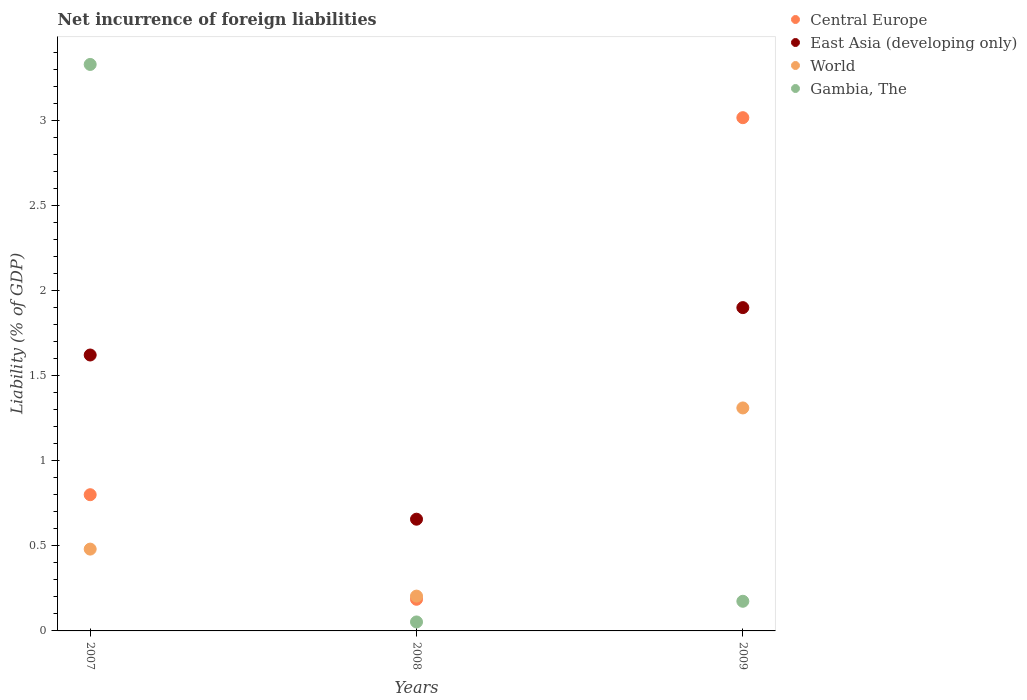What is the net incurrence of foreign liabilities in East Asia (developing only) in 2007?
Ensure brevity in your answer.  1.62. Across all years, what is the maximum net incurrence of foreign liabilities in Gambia, The?
Offer a very short reply. 3.33. Across all years, what is the minimum net incurrence of foreign liabilities in East Asia (developing only)?
Provide a short and direct response. 0.66. What is the total net incurrence of foreign liabilities in East Asia (developing only) in the graph?
Make the answer very short. 4.18. What is the difference between the net incurrence of foreign liabilities in Gambia, The in 2007 and that in 2008?
Give a very brief answer. 3.28. What is the difference between the net incurrence of foreign liabilities in World in 2007 and the net incurrence of foreign liabilities in Central Europe in 2008?
Your response must be concise. 0.29. What is the average net incurrence of foreign liabilities in World per year?
Provide a succinct answer. 0.67. In the year 2009, what is the difference between the net incurrence of foreign liabilities in World and net incurrence of foreign liabilities in East Asia (developing only)?
Make the answer very short. -0.59. What is the ratio of the net incurrence of foreign liabilities in Central Europe in 2007 to that in 2009?
Ensure brevity in your answer.  0.27. Is the difference between the net incurrence of foreign liabilities in World in 2008 and 2009 greater than the difference between the net incurrence of foreign liabilities in East Asia (developing only) in 2008 and 2009?
Your answer should be compact. Yes. What is the difference between the highest and the second highest net incurrence of foreign liabilities in East Asia (developing only)?
Your answer should be very brief. 0.28. What is the difference between the highest and the lowest net incurrence of foreign liabilities in East Asia (developing only)?
Offer a terse response. 1.24. In how many years, is the net incurrence of foreign liabilities in East Asia (developing only) greater than the average net incurrence of foreign liabilities in East Asia (developing only) taken over all years?
Offer a terse response. 2. Is it the case that in every year, the sum of the net incurrence of foreign liabilities in Gambia, The and net incurrence of foreign liabilities in East Asia (developing only)  is greater than the sum of net incurrence of foreign liabilities in World and net incurrence of foreign liabilities in Central Europe?
Offer a very short reply. No. How many years are there in the graph?
Offer a very short reply. 3. Are the values on the major ticks of Y-axis written in scientific E-notation?
Provide a succinct answer. No. Does the graph contain any zero values?
Offer a very short reply. No. Where does the legend appear in the graph?
Provide a short and direct response. Top right. How many legend labels are there?
Your answer should be very brief. 4. What is the title of the graph?
Offer a very short reply. Net incurrence of foreign liabilities. What is the label or title of the Y-axis?
Keep it short and to the point. Liability (% of GDP). What is the Liability (% of GDP) of Central Europe in 2007?
Offer a very short reply. 0.8. What is the Liability (% of GDP) of East Asia (developing only) in 2007?
Provide a succinct answer. 1.62. What is the Liability (% of GDP) of World in 2007?
Provide a succinct answer. 0.48. What is the Liability (% of GDP) in Gambia, The in 2007?
Your response must be concise. 3.33. What is the Liability (% of GDP) in Central Europe in 2008?
Offer a terse response. 0.19. What is the Liability (% of GDP) of East Asia (developing only) in 2008?
Keep it short and to the point. 0.66. What is the Liability (% of GDP) in World in 2008?
Your answer should be compact. 0.2. What is the Liability (% of GDP) in Gambia, The in 2008?
Provide a succinct answer. 0.05. What is the Liability (% of GDP) in Central Europe in 2009?
Provide a succinct answer. 3.02. What is the Liability (% of GDP) in East Asia (developing only) in 2009?
Offer a very short reply. 1.9. What is the Liability (% of GDP) of World in 2009?
Ensure brevity in your answer.  1.31. What is the Liability (% of GDP) of Gambia, The in 2009?
Your response must be concise. 0.17. Across all years, what is the maximum Liability (% of GDP) in Central Europe?
Your response must be concise. 3.02. Across all years, what is the maximum Liability (% of GDP) of East Asia (developing only)?
Offer a terse response. 1.9. Across all years, what is the maximum Liability (% of GDP) in World?
Ensure brevity in your answer.  1.31. Across all years, what is the maximum Liability (% of GDP) in Gambia, The?
Make the answer very short. 3.33. Across all years, what is the minimum Liability (% of GDP) in Central Europe?
Give a very brief answer. 0.19. Across all years, what is the minimum Liability (% of GDP) in East Asia (developing only)?
Your response must be concise. 0.66. Across all years, what is the minimum Liability (% of GDP) of World?
Keep it short and to the point. 0.2. Across all years, what is the minimum Liability (% of GDP) in Gambia, The?
Make the answer very short. 0.05. What is the total Liability (% of GDP) in Central Europe in the graph?
Provide a short and direct response. 4. What is the total Liability (% of GDP) of East Asia (developing only) in the graph?
Offer a very short reply. 4.18. What is the total Liability (% of GDP) in World in the graph?
Ensure brevity in your answer.  2. What is the total Liability (% of GDP) of Gambia, The in the graph?
Provide a succinct answer. 3.56. What is the difference between the Liability (% of GDP) of Central Europe in 2007 and that in 2008?
Provide a short and direct response. 0.61. What is the difference between the Liability (% of GDP) in East Asia (developing only) in 2007 and that in 2008?
Ensure brevity in your answer.  0.96. What is the difference between the Liability (% of GDP) of World in 2007 and that in 2008?
Provide a short and direct response. 0.28. What is the difference between the Liability (% of GDP) of Gambia, The in 2007 and that in 2008?
Make the answer very short. 3.28. What is the difference between the Liability (% of GDP) of Central Europe in 2007 and that in 2009?
Offer a very short reply. -2.22. What is the difference between the Liability (% of GDP) in East Asia (developing only) in 2007 and that in 2009?
Your answer should be very brief. -0.28. What is the difference between the Liability (% of GDP) in World in 2007 and that in 2009?
Offer a very short reply. -0.83. What is the difference between the Liability (% of GDP) of Gambia, The in 2007 and that in 2009?
Make the answer very short. 3.15. What is the difference between the Liability (% of GDP) of Central Europe in 2008 and that in 2009?
Make the answer very short. -2.83. What is the difference between the Liability (% of GDP) of East Asia (developing only) in 2008 and that in 2009?
Ensure brevity in your answer.  -1.24. What is the difference between the Liability (% of GDP) in World in 2008 and that in 2009?
Offer a terse response. -1.11. What is the difference between the Liability (% of GDP) in Gambia, The in 2008 and that in 2009?
Provide a succinct answer. -0.12. What is the difference between the Liability (% of GDP) in Central Europe in 2007 and the Liability (% of GDP) in East Asia (developing only) in 2008?
Provide a short and direct response. 0.14. What is the difference between the Liability (% of GDP) in Central Europe in 2007 and the Liability (% of GDP) in World in 2008?
Your answer should be compact. 0.6. What is the difference between the Liability (% of GDP) in Central Europe in 2007 and the Liability (% of GDP) in Gambia, The in 2008?
Your answer should be very brief. 0.75. What is the difference between the Liability (% of GDP) of East Asia (developing only) in 2007 and the Liability (% of GDP) of World in 2008?
Provide a succinct answer. 1.42. What is the difference between the Liability (% of GDP) of East Asia (developing only) in 2007 and the Liability (% of GDP) of Gambia, The in 2008?
Ensure brevity in your answer.  1.57. What is the difference between the Liability (% of GDP) in World in 2007 and the Liability (% of GDP) in Gambia, The in 2008?
Your answer should be compact. 0.43. What is the difference between the Liability (% of GDP) in Central Europe in 2007 and the Liability (% of GDP) in East Asia (developing only) in 2009?
Your response must be concise. -1.1. What is the difference between the Liability (% of GDP) of Central Europe in 2007 and the Liability (% of GDP) of World in 2009?
Make the answer very short. -0.51. What is the difference between the Liability (% of GDP) of Central Europe in 2007 and the Liability (% of GDP) of Gambia, The in 2009?
Your answer should be compact. 0.63. What is the difference between the Liability (% of GDP) in East Asia (developing only) in 2007 and the Liability (% of GDP) in World in 2009?
Your answer should be compact. 0.31. What is the difference between the Liability (% of GDP) of East Asia (developing only) in 2007 and the Liability (% of GDP) of Gambia, The in 2009?
Give a very brief answer. 1.45. What is the difference between the Liability (% of GDP) of World in 2007 and the Liability (% of GDP) of Gambia, The in 2009?
Offer a terse response. 0.31. What is the difference between the Liability (% of GDP) in Central Europe in 2008 and the Liability (% of GDP) in East Asia (developing only) in 2009?
Your answer should be compact. -1.71. What is the difference between the Liability (% of GDP) of Central Europe in 2008 and the Liability (% of GDP) of World in 2009?
Give a very brief answer. -1.12. What is the difference between the Liability (% of GDP) in Central Europe in 2008 and the Liability (% of GDP) in Gambia, The in 2009?
Provide a short and direct response. 0.01. What is the difference between the Liability (% of GDP) of East Asia (developing only) in 2008 and the Liability (% of GDP) of World in 2009?
Make the answer very short. -0.65. What is the difference between the Liability (% of GDP) of East Asia (developing only) in 2008 and the Liability (% of GDP) of Gambia, The in 2009?
Offer a very short reply. 0.48. What is the difference between the Liability (% of GDP) in World in 2008 and the Liability (% of GDP) in Gambia, The in 2009?
Your answer should be compact. 0.03. What is the average Liability (% of GDP) of Central Europe per year?
Your response must be concise. 1.33. What is the average Liability (% of GDP) of East Asia (developing only) per year?
Provide a succinct answer. 1.39. What is the average Liability (% of GDP) in World per year?
Your response must be concise. 0.67. What is the average Liability (% of GDP) in Gambia, The per year?
Offer a very short reply. 1.19. In the year 2007, what is the difference between the Liability (% of GDP) in Central Europe and Liability (% of GDP) in East Asia (developing only)?
Your response must be concise. -0.82. In the year 2007, what is the difference between the Liability (% of GDP) of Central Europe and Liability (% of GDP) of World?
Your answer should be compact. 0.32. In the year 2007, what is the difference between the Liability (% of GDP) in Central Europe and Liability (% of GDP) in Gambia, The?
Ensure brevity in your answer.  -2.53. In the year 2007, what is the difference between the Liability (% of GDP) of East Asia (developing only) and Liability (% of GDP) of World?
Your answer should be very brief. 1.14. In the year 2007, what is the difference between the Liability (% of GDP) in East Asia (developing only) and Liability (% of GDP) in Gambia, The?
Offer a very short reply. -1.71. In the year 2007, what is the difference between the Liability (% of GDP) of World and Liability (% of GDP) of Gambia, The?
Offer a terse response. -2.85. In the year 2008, what is the difference between the Liability (% of GDP) in Central Europe and Liability (% of GDP) in East Asia (developing only)?
Provide a succinct answer. -0.47. In the year 2008, what is the difference between the Liability (% of GDP) of Central Europe and Liability (% of GDP) of World?
Your response must be concise. -0.02. In the year 2008, what is the difference between the Liability (% of GDP) in Central Europe and Liability (% of GDP) in Gambia, The?
Your answer should be compact. 0.13. In the year 2008, what is the difference between the Liability (% of GDP) in East Asia (developing only) and Liability (% of GDP) in World?
Ensure brevity in your answer.  0.45. In the year 2008, what is the difference between the Liability (% of GDP) of East Asia (developing only) and Liability (% of GDP) of Gambia, The?
Offer a very short reply. 0.6. In the year 2008, what is the difference between the Liability (% of GDP) of World and Liability (% of GDP) of Gambia, The?
Make the answer very short. 0.15. In the year 2009, what is the difference between the Liability (% of GDP) of Central Europe and Liability (% of GDP) of East Asia (developing only)?
Your response must be concise. 1.12. In the year 2009, what is the difference between the Liability (% of GDP) of Central Europe and Liability (% of GDP) of World?
Provide a short and direct response. 1.71. In the year 2009, what is the difference between the Liability (% of GDP) in Central Europe and Liability (% of GDP) in Gambia, The?
Provide a short and direct response. 2.84. In the year 2009, what is the difference between the Liability (% of GDP) of East Asia (developing only) and Liability (% of GDP) of World?
Ensure brevity in your answer.  0.59. In the year 2009, what is the difference between the Liability (% of GDP) in East Asia (developing only) and Liability (% of GDP) in Gambia, The?
Ensure brevity in your answer.  1.73. In the year 2009, what is the difference between the Liability (% of GDP) of World and Liability (% of GDP) of Gambia, The?
Provide a succinct answer. 1.14. What is the ratio of the Liability (% of GDP) of Central Europe in 2007 to that in 2008?
Make the answer very short. 4.3. What is the ratio of the Liability (% of GDP) of East Asia (developing only) in 2007 to that in 2008?
Your answer should be compact. 2.47. What is the ratio of the Liability (% of GDP) of World in 2007 to that in 2008?
Provide a succinct answer. 2.35. What is the ratio of the Liability (% of GDP) of Gambia, The in 2007 to that in 2008?
Offer a very short reply. 63.14. What is the ratio of the Liability (% of GDP) of Central Europe in 2007 to that in 2009?
Provide a short and direct response. 0.27. What is the ratio of the Liability (% of GDP) of East Asia (developing only) in 2007 to that in 2009?
Your answer should be very brief. 0.85. What is the ratio of the Liability (% of GDP) of World in 2007 to that in 2009?
Make the answer very short. 0.37. What is the ratio of the Liability (% of GDP) of Gambia, The in 2007 to that in 2009?
Give a very brief answer. 19.11. What is the ratio of the Liability (% of GDP) in Central Europe in 2008 to that in 2009?
Offer a very short reply. 0.06. What is the ratio of the Liability (% of GDP) in East Asia (developing only) in 2008 to that in 2009?
Your answer should be compact. 0.35. What is the ratio of the Liability (% of GDP) in World in 2008 to that in 2009?
Your answer should be compact. 0.16. What is the ratio of the Liability (% of GDP) in Gambia, The in 2008 to that in 2009?
Your response must be concise. 0.3. What is the difference between the highest and the second highest Liability (% of GDP) in Central Europe?
Make the answer very short. 2.22. What is the difference between the highest and the second highest Liability (% of GDP) in East Asia (developing only)?
Ensure brevity in your answer.  0.28. What is the difference between the highest and the second highest Liability (% of GDP) of World?
Keep it short and to the point. 0.83. What is the difference between the highest and the second highest Liability (% of GDP) in Gambia, The?
Provide a succinct answer. 3.15. What is the difference between the highest and the lowest Liability (% of GDP) of Central Europe?
Your response must be concise. 2.83. What is the difference between the highest and the lowest Liability (% of GDP) in East Asia (developing only)?
Give a very brief answer. 1.24. What is the difference between the highest and the lowest Liability (% of GDP) in World?
Your response must be concise. 1.11. What is the difference between the highest and the lowest Liability (% of GDP) in Gambia, The?
Provide a succinct answer. 3.28. 